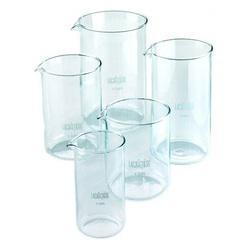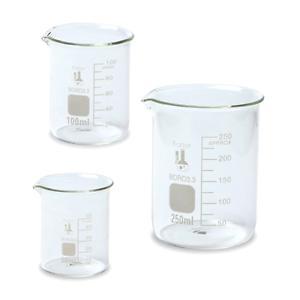The first image is the image on the left, the second image is the image on the right. Examine the images to the left and right. Is the description "Exactly five beakers in one image and three in the other image are all empty and different sizes." accurate? Answer yes or no. Yes. The first image is the image on the left, the second image is the image on the right. Considering the images on both sides, is "There are exactly 3 beakers in one of the images." valid? Answer yes or no. Yes. 